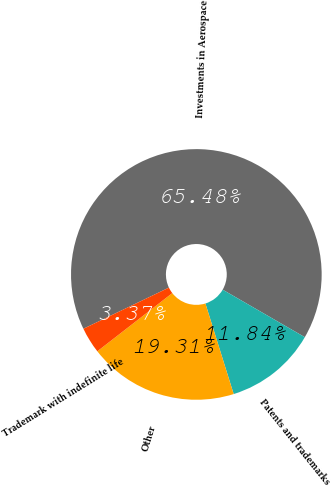Convert chart. <chart><loc_0><loc_0><loc_500><loc_500><pie_chart><fcel>Investments in Aerospace<fcel>Patents and trademarks<fcel>Other<fcel>Trademark with indefinite life<nl><fcel>65.48%<fcel>11.84%<fcel>19.31%<fcel>3.37%<nl></chart> 